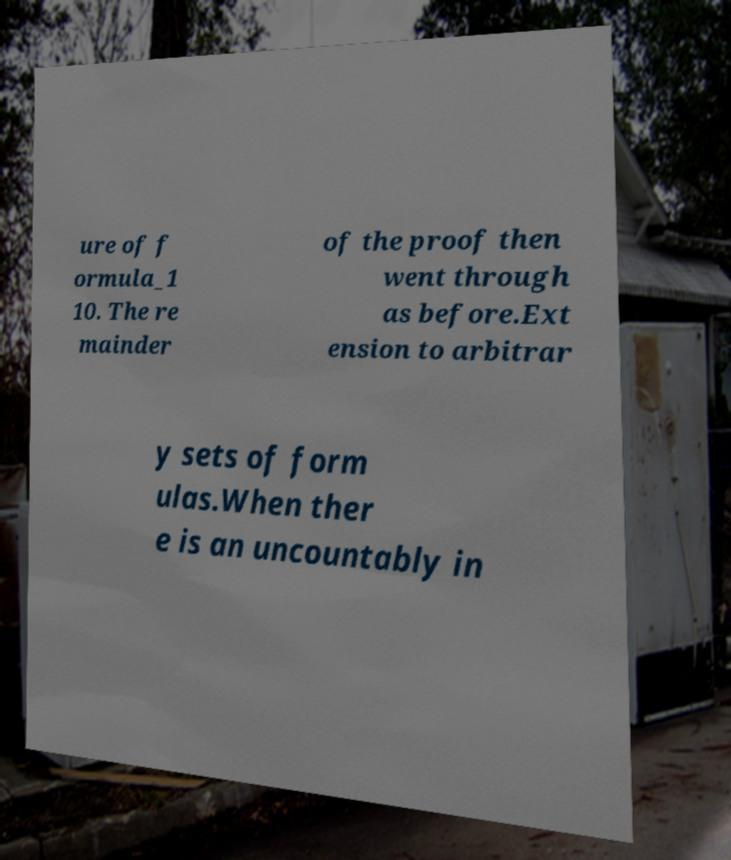What messages or text are displayed in this image? I need them in a readable, typed format. ure of f ormula_1 10. The re mainder of the proof then went through as before.Ext ension to arbitrar y sets of form ulas.When ther e is an uncountably in 